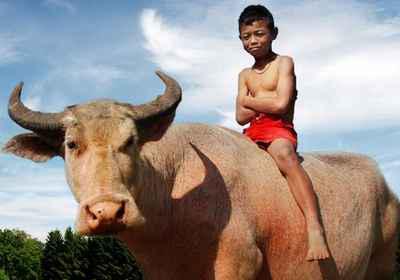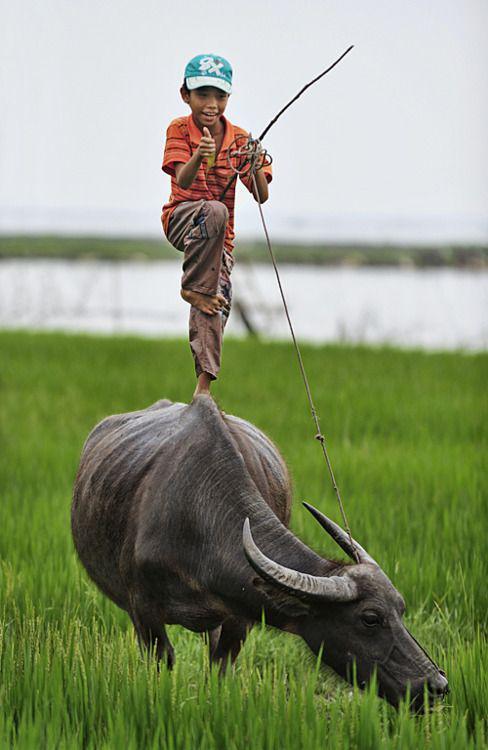The first image is the image on the left, the second image is the image on the right. For the images shown, is this caption "A small boy straddles a horned cow in the image on the left." true? Answer yes or no. Yes. The first image is the image on the left, the second image is the image on the right. Considering the images on both sides, is "Each image features a young boy on top of a water buffalo's back, but only the left image shows a boy sitting with his legs dangling over the sides of the animal." valid? Answer yes or no. Yes. 